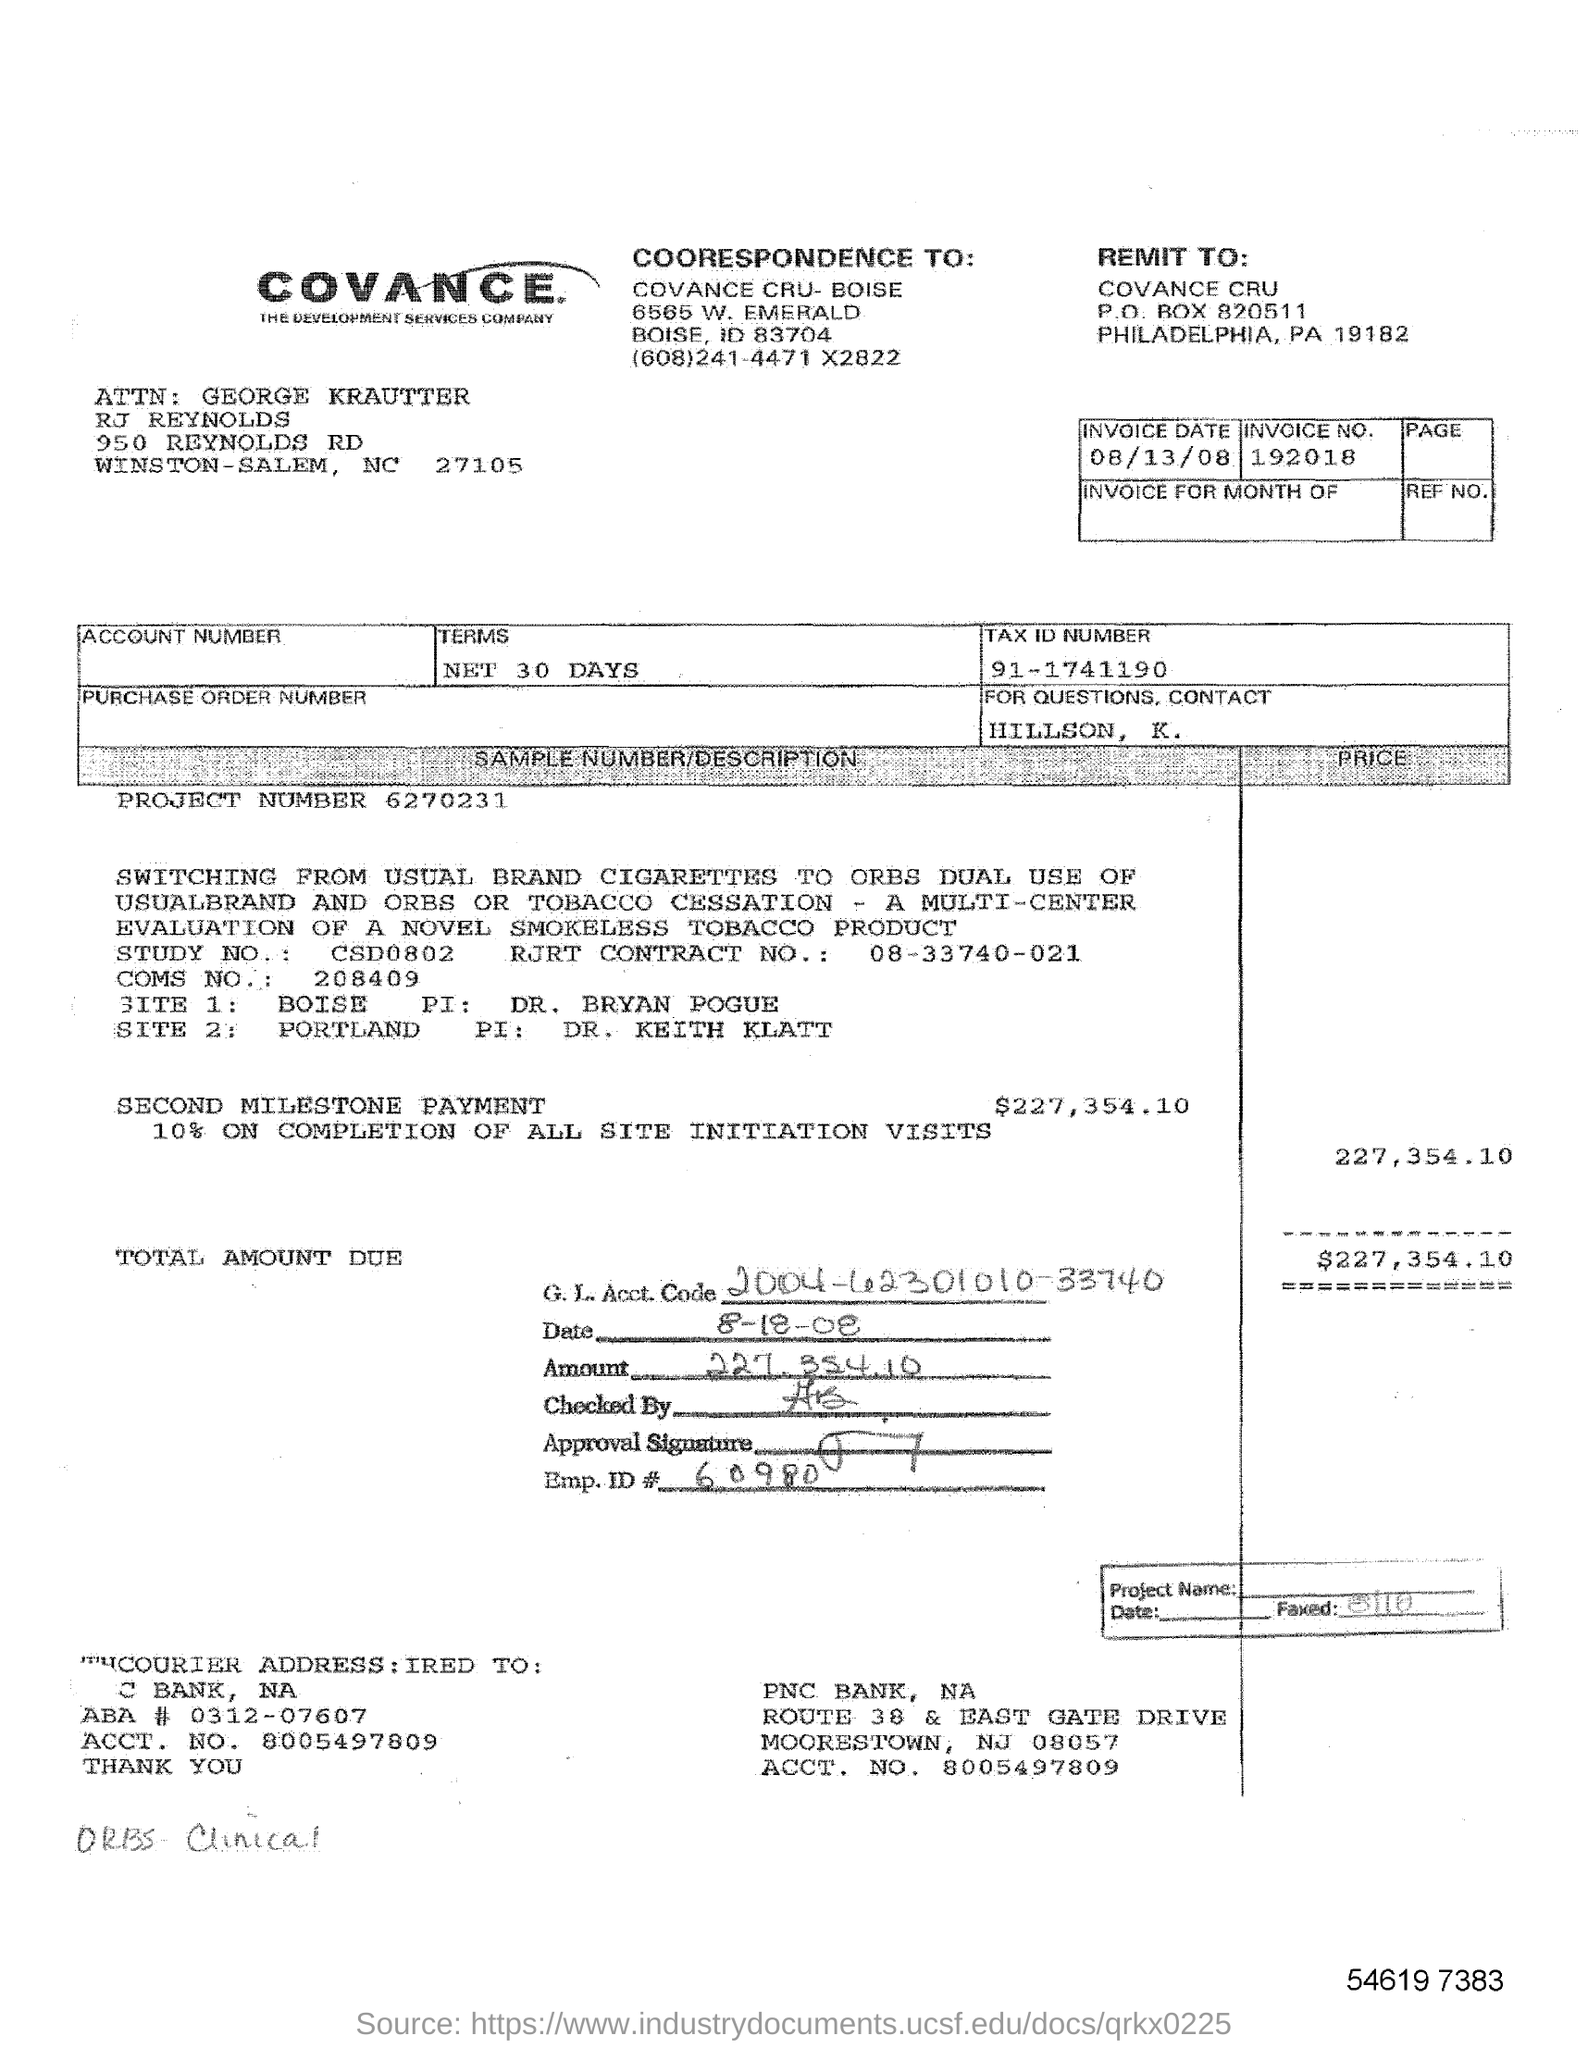What is the PROJECT NUMBER?
Your response must be concise. 6270231. What is the INVOICE NO. ?
Offer a very short reply. 192018. What is the INVOICE DATE ?
Your answer should be compact. 08/13/08. What is the INVOICE NO ?
Your response must be concise. 192018. What is TAX ID NUMBER?
Make the answer very short. 91-1741190. 